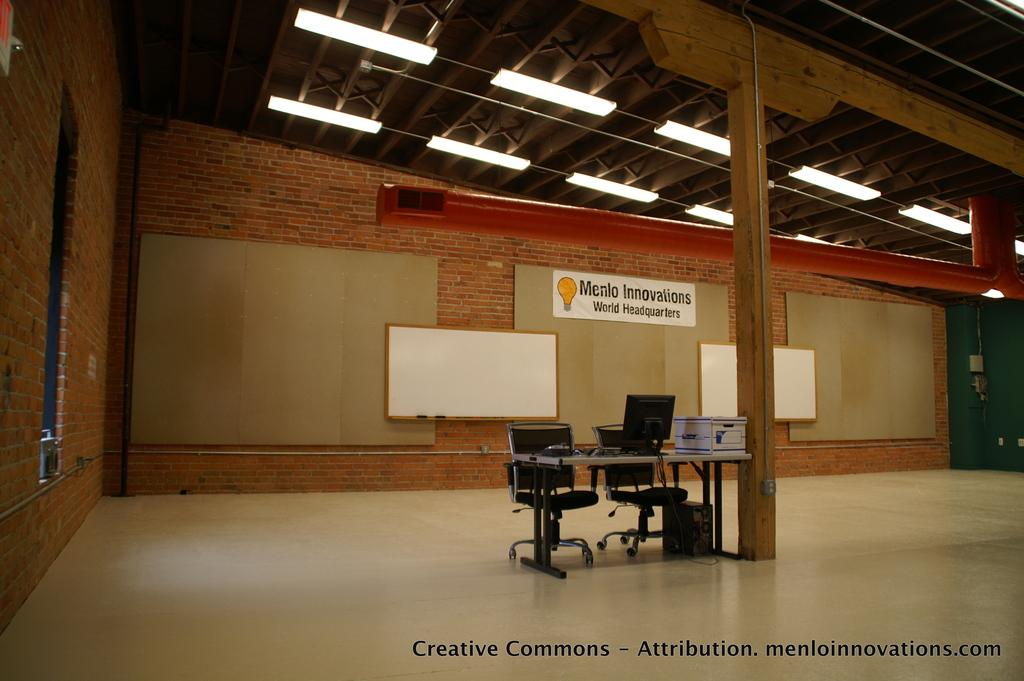What type of space is depicted in the image? The image shows an inside view of a room. What furniture is present in the room? There are chairs and a table in the room. What is the purpose of the board in the room? The purpose of the board is not specified, but it could be used for displaying information or as a writing surface. What are the boundaries of the room? The room has walls and a roof. What is used for illumination in the room? There are lights in the room. What type of powder is being used to clean the pail in the image? There is no pail or powder present in the image. What items are on the list that is hanging on the wall in the image? There is no list hanging on the wall in the image. 